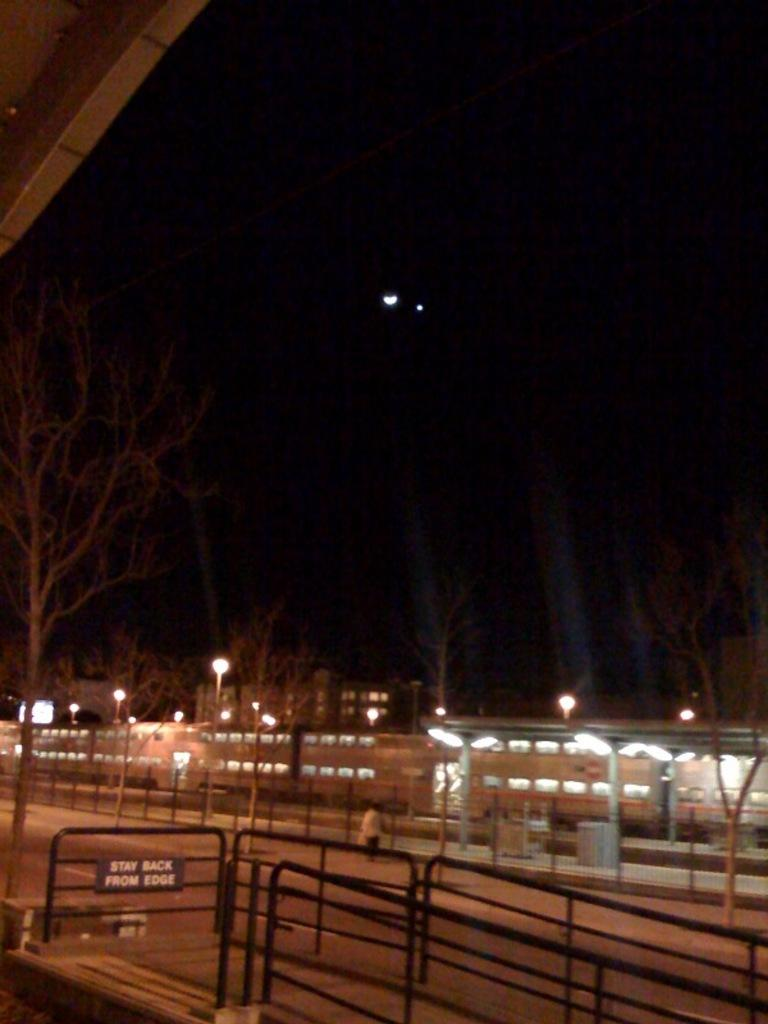What can be seen in the image that might be used for support or safety? There is a railing in the image that can be used for support or safety. Who or what is present in the image? There is a person in the image. What can be seen in the background of the image? There are many lights and trees in the background of the image. What is the color of the background in the image? The background of the image is black. What time of day is it in the image, considering the presence of the morning? The time of day cannot be determined from the image, as there is no reference to morning or any other time of day. What type of bee can be seen interacting with the person in the image? There are no bees present in the image; only a person and a railing are visible. 